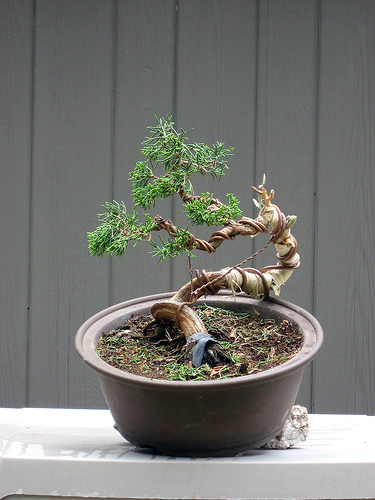<image>
Is the bonsai in the pot? Yes. The bonsai is contained within or inside the pot, showing a containment relationship. 